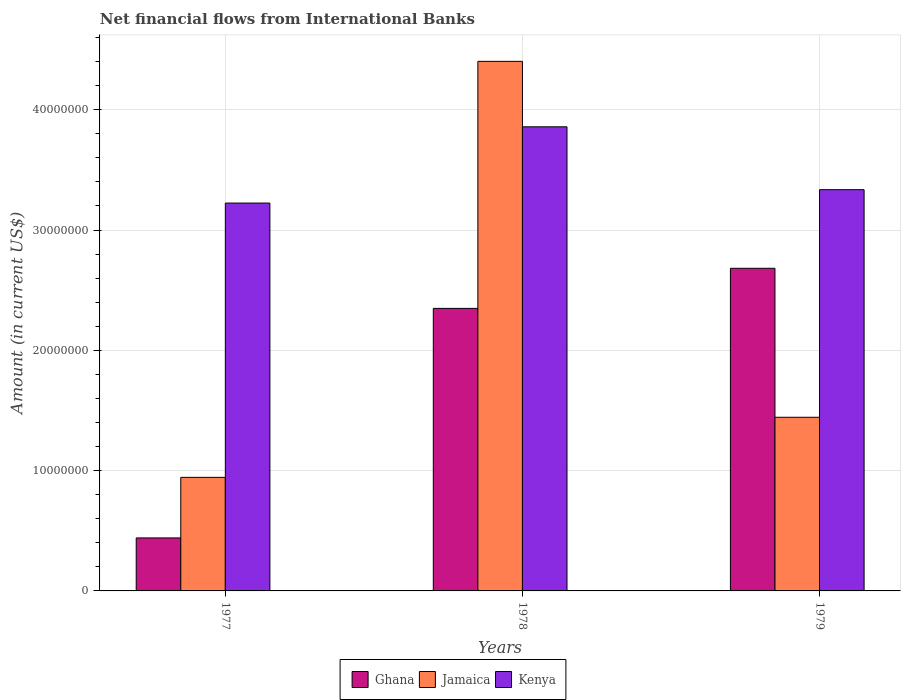How many groups of bars are there?
Your answer should be very brief. 3. Are the number of bars on each tick of the X-axis equal?
Provide a succinct answer. Yes. How many bars are there on the 1st tick from the left?
Provide a short and direct response. 3. What is the label of the 3rd group of bars from the left?
Provide a short and direct response. 1979. In how many cases, is the number of bars for a given year not equal to the number of legend labels?
Offer a terse response. 0. What is the net financial aid flows in Ghana in 1977?
Your answer should be compact. 4.41e+06. Across all years, what is the maximum net financial aid flows in Jamaica?
Your answer should be compact. 4.40e+07. Across all years, what is the minimum net financial aid flows in Jamaica?
Provide a succinct answer. 9.44e+06. In which year was the net financial aid flows in Kenya maximum?
Provide a succinct answer. 1978. What is the total net financial aid flows in Jamaica in the graph?
Provide a short and direct response. 6.79e+07. What is the difference between the net financial aid flows in Jamaica in 1977 and that in 1979?
Keep it short and to the point. -4.99e+06. What is the difference between the net financial aid flows in Ghana in 1977 and the net financial aid flows in Jamaica in 1979?
Ensure brevity in your answer.  -1.00e+07. What is the average net financial aid flows in Kenya per year?
Offer a very short reply. 3.47e+07. In the year 1977, what is the difference between the net financial aid flows in Jamaica and net financial aid flows in Ghana?
Give a very brief answer. 5.04e+06. What is the ratio of the net financial aid flows in Ghana in 1978 to that in 1979?
Provide a succinct answer. 0.88. Is the net financial aid flows in Jamaica in 1977 less than that in 1979?
Provide a succinct answer. Yes. What is the difference between the highest and the second highest net financial aid flows in Kenya?
Make the answer very short. 5.22e+06. What is the difference between the highest and the lowest net financial aid flows in Kenya?
Provide a short and direct response. 6.34e+06. In how many years, is the net financial aid flows in Kenya greater than the average net financial aid flows in Kenya taken over all years?
Your answer should be compact. 1. Is the sum of the net financial aid flows in Kenya in 1978 and 1979 greater than the maximum net financial aid flows in Jamaica across all years?
Provide a short and direct response. Yes. What does the 3rd bar from the left in 1977 represents?
Make the answer very short. Kenya. What does the 2nd bar from the right in 1979 represents?
Provide a succinct answer. Jamaica. Is it the case that in every year, the sum of the net financial aid flows in Ghana and net financial aid flows in Kenya is greater than the net financial aid flows in Jamaica?
Your answer should be very brief. Yes. How many bars are there?
Offer a terse response. 9. Are all the bars in the graph horizontal?
Make the answer very short. No. How many years are there in the graph?
Give a very brief answer. 3. What is the difference between two consecutive major ticks on the Y-axis?
Your answer should be very brief. 1.00e+07. Are the values on the major ticks of Y-axis written in scientific E-notation?
Your response must be concise. No. Does the graph contain any zero values?
Give a very brief answer. No. How many legend labels are there?
Provide a succinct answer. 3. What is the title of the graph?
Give a very brief answer. Net financial flows from International Banks. Does "Low income" appear as one of the legend labels in the graph?
Provide a short and direct response. No. What is the label or title of the X-axis?
Offer a very short reply. Years. What is the Amount (in current US$) of Ghana in 1977?
Your answer should be very brief. 4.41e+06. What is the Amount (in current US$) in Jamaica in 1977?
Provide a succinct answer. 9.44e+06. What is the Amount (in current US$) in Kenya in 1977?
Your response must be concise. 3.22e+07. What is the Amount (in current US$) in Ghana in 1978?
Provide a short and direct response. 2.35e+07. What is the Amount (in current US$) of Jamaica in 1978?
Your answer should be very brief. 4.40e+07. What is the Amount (in current US$) in Kenya in 1978?
Your answer should be very brief. 3.86e+07. What is the Amount (in current US$) in Ghana in 1979?
Ensure brevity in your answer.  2.68e+07. What is the Amount (in current US$) in Jamaica in 1979?
Your response must be concise. 1.44e+07. What is the Amount (in current US$) of Kenya in 1979?
Your response must be concise. 3.34e+07. Across all years, what is the maximum Amount (in current US$) of Ghana?
Your answer should be compact. 2.68e+07. Across all years, what is the maximum Amount (in current US$) in Jamaica?
Keep it short and to the point. 4.40e+07. Across all years, what is the maximum Amount (in current US$) in Kenya?
Your answer should be very brief. 3.86e+07. Across all years, what is the minimum Amount (in current US$) in Ghana?
Keep it short and to the point. 4.41e+06. Across all years, what is the minimum Amount (in current US$) in Jamaica?
Make the answer very short. 9.44e+06. Across all years, what is the minimum Amount (in current US$) in Kenya?
Provide a succinct answer. 3.22e+07. What is the total Amount (in current US$) in Ghana in the graph?
Offer a very short reply. 5.47e+07. What is the total Amount (in current US$) of Jamaica in the graph?
Your response must be concise. 6.79e+07. What is the total Amount (in current US$) of Kenya in the graph?
Provide a succinct answer. 1.04e+08. What is the difference between the Amount (in current US$) in Ghana in 1977 and that in 1978?
Your response must be concise. -1.91e+07. What is the difference between the Amount (in current US$) of Jamaica in 1977 and that in 1978?
Make the answer very short. -3.46e+07. What is the difference between the Amount (in current US$) in Kenya in 1977 and that in 1978?
Give a very brief answer. -6.34e+06. What is the difference between the Amount (in current US$) in Ghana in 1977 and that in 1979?
Make the answer very short. -2.24e+07. What is the difference between the Amount (in current US$) of Jamaica in 1977 and that in 1979?
Offer a terse response. -4.99e+06. What is the difference between the Amount (in current US$) of Kenya in 1977 and that in 1979?
Your answer should be compact. -1.11e+06. What is the difference between the Amount (in current US$) of Ghana in 1978 and that in 1979?
Provide a succinct answer. -3.33e+06. What is the difference between the Amount (in current US$) in Jamaica in 1978 and that in 1979?
Your answer should be very brief. 2.96e+07. What is the difference between the Amount (in current US$) of Kenya in 1978 and that in 1979?
Keep it short and to the point. 5.22e+06. What is the difference between the Amount (in current US$) of Ghana in 1977 and the Amount (in current US$) of Jamaica in 1978?
Make the answer very short. -3.96e+07. What is the difference between the Amount (in current US$) of Ghana in 1977 and the Amount (in current US$) of Kenya in 1978?
Offer a very short reply. -3.42e+07. What is the difference between the Amount (in current US$) of Jamaica in 1977 and the Amount (in current US$) of Kenya in 1978?
Your answer should be compact. -2.91e+07. What is the difference between the Amount (in current US$) of Ghana in 1977 and the Amount (in current US$) of Jamaica in 1979?
Your answer should be compact. -1.00e+07. What is the difference between the Amount (in current US$) of Ghana in 1977 and the Amount (in current US$) of Kenya in 1979?
Offer a very short reply. -2.90e+07. What is the difference between the Amount (in current US$) in Jamaica in 1977 and the Amount (in current US$) in Kenya in 1979?
Your answer should be compact. -2.39e+07. What is the difference between the Amount (in current US$) in Ghana in 1978 and the Amount (in current US$) in Jamaica in 1979?
Offer a very short reply. 9.05e+06. What is the difference between the Amount (in current US$) of Ghana in 1978 and the Amount (in current US$) of Kenya in 1979?
Give a very brief answer. -9.87e+06. What is the difference between the Amount (in current US$) of Jamaica in 1978 and the Amount (in current US$) of Kenya in 1979?
Your answer should be compact. 1.07e+07. What is the average Amount (in current US$) of Ghana per year?
Offer a very short reply. 1.82e+07. What is the average Amount (in current US$) in Jamaica per year?
Offer a terse response. 2.26e+07. What is the average Amount (in current US$) in Kenya per year?
Make the answer very short. 3.47e+07. In the year 1977, what is the difference between the Amount (in current US$) in Ghana and Amount (in current US$) in Jamaica?
Provide a succinct answer. -5.04e+06. In the year 1977, what is the difference between the Amount (in current US$) in Ghana and Amount (in current US$) in Kenya?
Offer a very short reply. -2.78e+07. In the year 1977, what is the difference between the Amount (in current US$) of Jamaica and Amount (in current US$) of Kenya?
Ensure brevity in your answer.  -2.28e+07. In the year 1978, what is the difference between the Amount (in current US$) of Ghana and Amount (in current US$) of Jamaica?
Give a very brief answer. -2.05e+07. In the year 1978, what is the difference between the Amount (in current US$) in Ghana and Amount (in current US$) in Kenya?
Keep it short and to the point. -1.51e+07. In the year 1978, what is the difference between the Amount (in current US$) in Jamaica and Amount (in current US$) in Kenya?
Provide a short and direct response. 5.44e+06. In the year 1979, what is the difference between the Amount (in current US$) of Ghana and Amount (in current US$) of Jamaica?
Ensure brevity in your answer.  1.24e+07. In the year 1979, what is the difference between the Amount (in current US$) of Ghana and Amount (in current US$) of Kenya?
Your answer should be compact. -6.54e+06. In the year 1979, what is the difference between the Amount (in current US$) of Jamaica and Amount (in current US$) of Kenya?
Make the answer very short. -1.89e+07. What is the ratio of the Amount (in current US$) of Ghana in 1977 to that in 1978?
Give a very brief answer. 0.19. What is the ratio of the Amount (in current US$) in Jamaica in 1977 to that in 1978?
Provide a short and direct response. 0.21. What is the ratio of the Amount (in current US$) of Kenya in 1977 to that in 1978?
Your answer should be compact. 0.84. What is the ratio of the Amount (in current US$) of Ghana in 1977 to that in 1979?
Provide a succinct answer. 0.16. What is the ratio of the Amount (in current US$) in Jamaica in 1977 to that in 1979?
Ensure brevity in your answer.  0.65. What is the ratio of the Amount (in current US$) of Kenya in 1977 to that in 1979?
Give a very brief answer. 0.97. What is the ratio of the Amount (in current US$) of Ghana in 1978 to that in 1979?
Your answer should be compact. 0.88. What is the ratio of the Amount (in current US$) in Jamaica in 1978 to that in 1979?
Offer a terse response. 3.05. What is the ratio of the Amount (in current US$) in Kenya in 1978 to that in 1979?
Give a very brief answer. 1.16. What is the difference between the highest and the second highest Amount (in current US$) in Ghana?
Provide a short and direct response. 3.33e+06. What is the difference between the highest and the second highest Amount (in current US$) of Jamaica?
Your response must be concise. 2.96e+07. What is the difference between the highest and the second highest Amount (in current US$) in Kenya?
Your answer should be very brief. 5.22e+06. What is the difference between the highest and the lowest Amount (in current US$) of Ghana?
Provide a succinct answer. 2.24e+07. What is the difference between the highest and the lowest Amount (in current US$) in Jamaica?
Keep it short and to the point. 3.46e+07. What is the difference between the highest and the lowest Amount (in current US$) in Kenya?
Ensure brevity in your answer.  6.34e+06. 